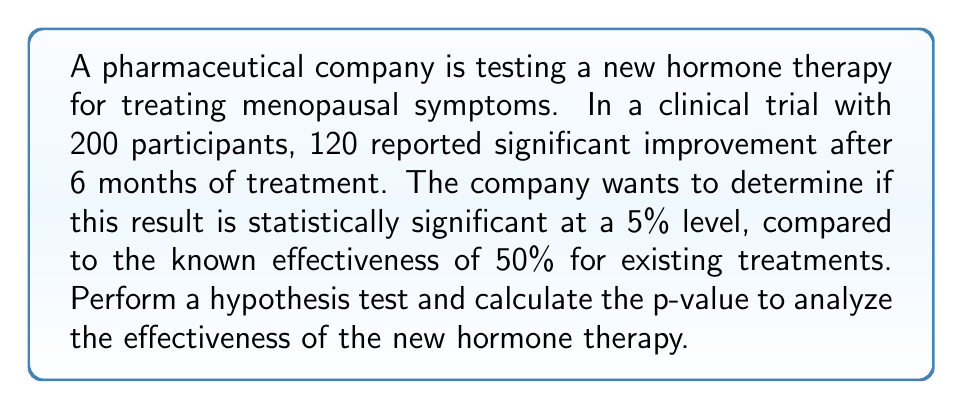Can you answer this question? Let's approach this step-by-step using a one-tailed z-test for proportions:

1) Define the hypotheses:
   $H_0: p = 0.5$ (null hypothesis: new therapy is as effective as existing treatments)
   $H_a: p > 0.5$ (alternative hypothesis: new therapy is more effective)

2) Calculate the sample proportion:
   $\hat{p} = \frac{120}{200} = 0.6$

3) Calculate the standard error:
   $SE = \sqrt{\frac{p_0(1-p_0)}{n}} = \sqrt{\frac{0.5(1-0.5)}{200}} = 0.0354$

4) Calculate the z-score:
   $z = \frac{\hat{p} - p_0}{SE} = \frac{0.6 - 0.5}{0.0354} = 2.83$

5) Find the p-value:
   The p-value is the area to the right of z = 2.83 in the standard normal distribution.
   Using a z-table or calculator, we find:
   p-value $= 1 - \Phi(2.83) \approx 0.0023$

6) Compare the p-value to the significance level:
   0.0023 < 0.05

Since the p-value (0.0023) is less than the significance level (0.05), we reject the null hypothesis.
Answer: p-value ≈ 0.0023; reject $H_0$ 